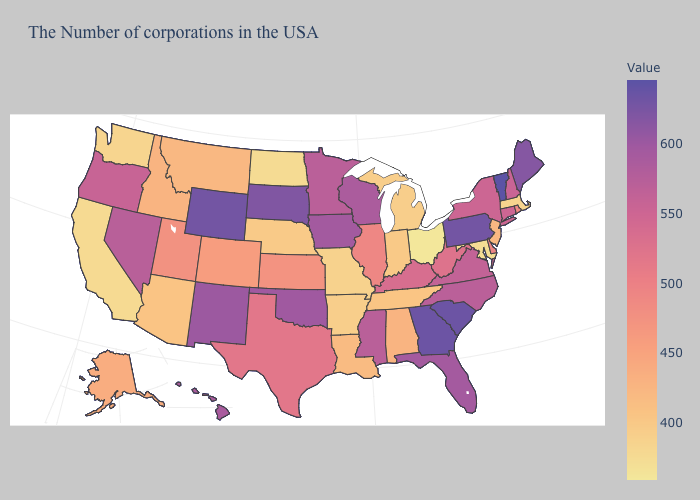Among the states that border Rhode Island , which have the highest value?
Short answer required. Connecticut. Does Vermont have the highest value in the USA?
Short answer required. Yes. Is the legend a continuous bar?
Give a very brief answer. Yes. Does the map have missing data?
Give a very brief answer. No. 